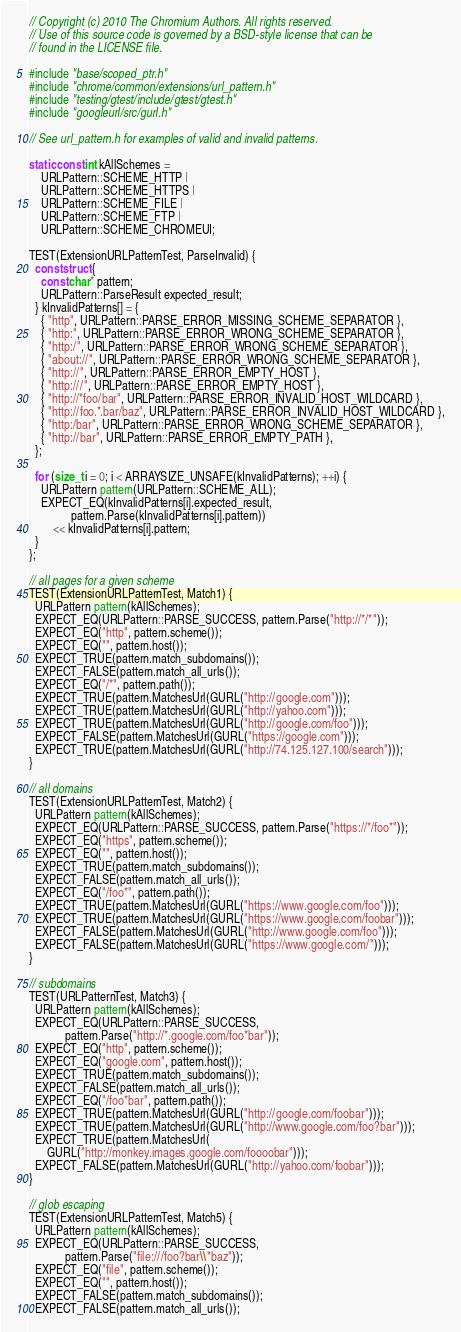<code> <loc_0><loc_0><loc_500><loc_500><_C++_>// Copyright (c) 2010 The Chromium Authors. All rights reserved.
// Use of this source code is governed by a BSD-style license that can be
// found in the LICENSE file.

#include "base/scoped_ptr.h"
#include "chrome/common/extensions/url_pattern.h"
#include "testing/gtest/include/gtest/gtest.h"
#include "googleurl/src/gurl.h"

// See url_pattern.h for examples of valid and invalid patterns.

static const int kAllSchemes =
    URLPattern::SCHEME_HTTP |
    URLPattern::SCHEME_HTTPS |
    URLPattern::SCHEME_FILE |
    URLPattern::SCHEME_FTP |
    URLPattern::SCHEME_CHROMEUI;

TEST(ExtensionURLPatternTest, ParseInvalid) {
  const struct {
    const char* pattern;
    URLPattern::ParseResult expected_result;
  } kInvalidPatterns[] = {
    { "http", URLPattern::PARSE_ERROR_MISSING_SCHEME_SEPARATOR },
    { "http:", URLPattern::PARSE_ERROR_WRONG_SCHEME_SEPARATOR },
    { "http:/", URLPattern::PARSE_ERROR_WRONG_SCHEME_SEPARATOR },
    { "about://", URLPattern::PARSE_ERROR_WRONG_SCHEME_SEPARATOR },
    { "http://", URLPattern::PARSE_ERROR_EMPTY_HOST },
    { "http:///", URLPattern::PARSE_ERROR_EMPTY_HOST },
    { "http://*foo/bar", URLPattern::PARSE_ERROR_INVALID_HOST_WILDCARD },
    { "http://foo.*.bar/baz", URLPattern::PARSE_ERROR_INVALID_HOST_WILDCARD },
    { "http:/bar", URLPattern::PARSE_ERROR_WRONG_SCHEME_SEPARATOR },
    { "http://bar", URLPattern::PARSE_ERROR_EMPTY_PATH },
  };

  for (size_t i = 0; i < ARRAYSIZE_UNSAFE(kInvalidPatterns); ++i) {
    URLPattern pattern(URLPattern::SCHEME_ALL);
    EXPECT_EQ(kInvalidPatterns[i].expected_result,
              pattern.Parse(kInvalidPatterns[i].pattern))
        << kInvalidPatterns[i].pattern;
  }
};

// all pages for a given scheme
TEST(ExtensionURLPatternTest, Match1) {
  URLPattern pattern(kAllSchemes);
  EXPECT_EQ(URLPattern::PARSE_SUCCESS, pattern.Parse("http://*/*"));
  EXPECT_EQ("http", pattern.scheme());
  EXPECT_EQ("", pattern.host());
  EXPECT_TRUE(pattern.match_subdomains());
  EXPECT_FALSE(pattern.match_all_urls());
  EXPECT_EQ("/*", pattern.path());
  EXPECT_TRUE(pattern.MatchesUrl(GURL("http://google.com")));
  EXPECT_TRUE(pattern.MatchesUrl(GURL("http://yahoo.com")));
  EXPECT_TRUE(pattern.MatchesUrl(GURL("http://google.com/foo")));
  EXPECT_FALSE(pattern.MatchesUrl(GURL("https://google.com")));
  EXPECT_TRUE(pattern.MatchesUrl(GURL("http://74.125.127.100/search")));
}

// all domains
TEST(ExtensionURLPatternTest, Match2) {
  URLPattern pattern(kAllSchemes);
  EXPECT_EQ(URLPattern::PARSE_SUCCESS, pattern.Parse("https://*/foo*"));
  EXPECT_EQ("https", pattern.scheme());
  EXPECT_EQ("", pattern.host());
  EXPECT_TRUE(pattern.match_subdomains());
  EXPECT_FALSE(pattern.match_all_urls());
  EXPECT_EQ("/foo*", pattern.path());
  EXPECT_TRUE(pattern.MatchesUrl(GURL("https://www.google.com/foo")));
  EXPECT_TRUE(pattern.MatchesUrl(GURL("https://www.google.com/foobar")));
  EXPECT_FALSE(pattern.MatchesUrl(GURL("http://www.google.com/foo")));
  EXPECT_FALSE(pattern.MatchesUrl(GURL("https://www.google.com/")));
}

// subdomains
TEST(URLPatternTest, Match3) {
  URLPattern pattern(kAllSchemes);
  EXPECT_EQ(URLPattern::PARSE_SUCCESS,
            pattern.Parse("http://*.google.com/foo*bar"));
  EXPECT_EQ("http", pattern.scheme());
  EXPECT_EQ("google.com", pattern.host());
  EXPECT_TRUE(pattern.match_subdomains());
  EXPECT_FALSE(pattern.match_all_urls());
  EXPECT_EQ("/foo*bar", pattern.path());
  EXPECT_TRUE(pattern.MatchesUrl(GURL("http://google.com/foobar")));
  EXPECT_TRUE(pattern.MatchesUrl(GURL("http://www.google.com/foo?bar")));
  EXPECT_TRUE(pattern.MatchesUrl(
      GURL("http://monkey.images.google.com/foooobar")));
  EXPECT_FALSE(pattern.MatchesUrl(GURL("http://yahoo.com/foobar")));
}

// glob escaping
TEST(ExtensionURLPatternTest, Match5) {
  URLPattern pattern(kAllSchemes);
  EXPECT_EQ(URLPattern::PARSE_SUCCESS,
            pattern.Parse("file:///foo?bar\\*baz"));
  EXPECT_EQ("file", pattern.scheme());
  EXPECT_EQ("", pattern.host());
  EXPECT_FALSE(pattern.match_subdomains());
  EXPECT_FALSE(pattern.match_all_urls());</code> 